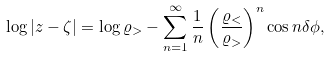Convert formula to latex. <formula><loc_0><loc_0><loc_500><loc_500>\log | z - \zeta | = \log \varrho _ { > } - \sum _ { n = 1 } ^ { \infty } \frac { 1 } { n } \left ( \frac { \varrho _ { < } } { \varrho _ { > } } \right ) ^ { n } \cos n \delta \phi ,</formula> 